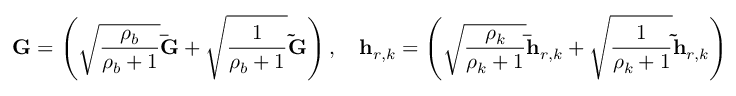<formula> <loc_0><loc_0><loc_500><loc_500>G = \left ( \sqrt { \frac { \rho _ { b } } { \rho _ { b } + 1 } } \bar { G } + \sqrt { \frac { 1 } { \rho _ { b } + 1 } } \tilde { G } \right ) , \quad h _ { r , k } = \left ( \sqrt { \frac { \rho _ { k } } { \rho _ { k } + 1 } } \bar { h } _ { r , k } + \sqrt { \frac { 1 } { \rho _ { k } + 1 } } \tilde { h } _ { r , k } \right )</formula> 